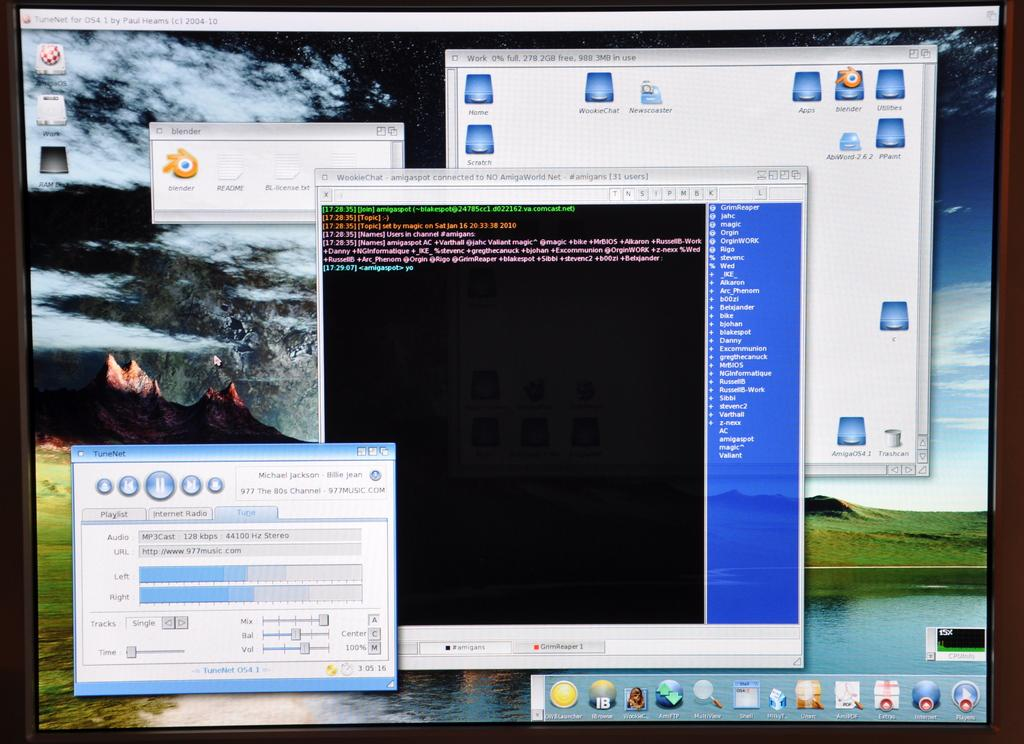<image>
Describe the image concisely. A computer monitor with multiple windows open and running blender. 